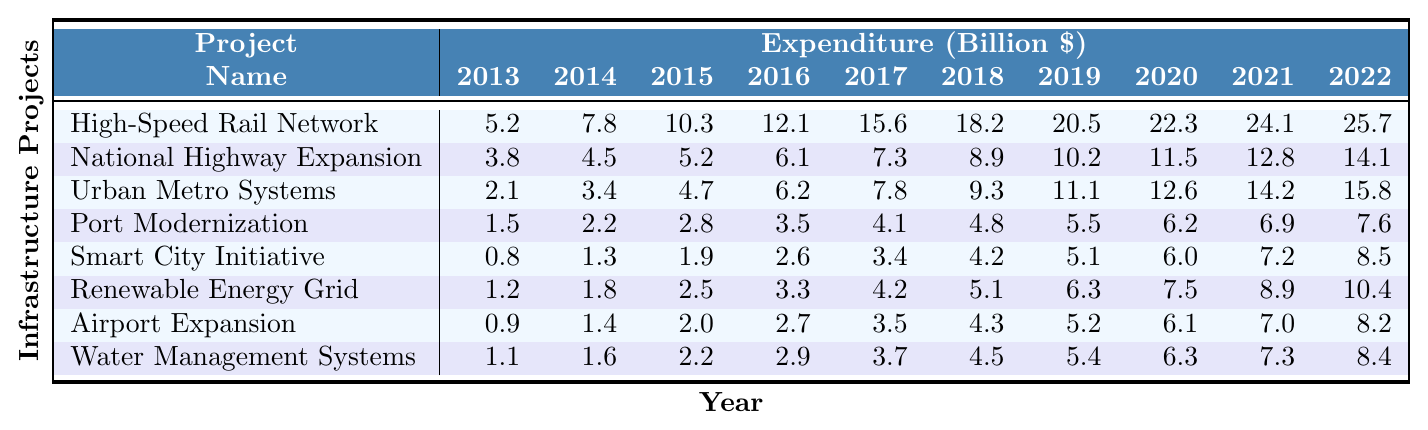What was the highest expenditure in the year 2022? By inspecting the table, the expenditures for 2022 across various projects are: High-Speed Rail Network (25.7), National Highway Expansion (14.1), Urban Metro Systems (15.8), Port Modernization (7.6), Smart City Initiative (8.5), Renewable Energy Grid (10.4), Airport Expansion (8.2), and Water Management Systems (8.4). The highest among these is 25.7 from the High-Speed Rail Network.
Answer: 25.7 Which project had the lowest expenditure in 2013? In 2013, the expenditures for the projects are as follows: High-Speed Rail Network (5.2), National Highway Expansion (3.8), Urban Metro Systems (2.1), Port Modernization (1.5), Smart City Initiative (0.8), Renewable Energy Grid (1.2), Airport Expansion (0.9), and Water Management Systems (1.1). The lowest expenditure is 0.8 from the Smart City Initiative.
Answer: 0.8 What is the average expenditure for the Urban Metro Systems over the decade? The expenditures for Urban Metro Systems are: 2.1, 3.4, 4.7, 6.2, 7.8, 9.3, 11.1, 12.6, 14.2, and 15.8. First, sum them up: (2.1 + 3.4 + 4.7 + 6.2 + 7.8 + 9.3 + 11.1 + 12.6 + 14.2 + 15.8) = 77.2. There are 10 data points, so the average is 77.2 divided by 10, which equals 7.72.
Answer: 7.72 Did the expenditure for the Renewable Energy Grid increase every year from 2013 to 2022? Looking at the table for the Renewable Energy Grid, the expenditures are: 1.2, 1.8, 2.5, 3.3, 4.2, 5.1, 6.3, 7.5, 8.9, and 10.4. Each subsequent year shows a higher expenditure than the previous year. Thus, yes, it did increase every year.
Answer: Yes What was the total expenditure for all projects in 2020? To find the total expenditure in 2020, add up each project’s expenditure: High-Speed Rail Network (22.3), National Highway Expansion (11.5), Urban Metro Systems (12.6), Port Modernization (6.2), Smart City Initiative (6.0), Renewable Energy Grid (7.5), Airport Expansion (6.1), and Water Management Systems (6.3). The total is: (22.3 + 11.5 + 12.6 + 6.2 + 6.0 + 7.5 + 6.1 + 6.3) = 78.5.
Answer: 78.5 Which project saw the largest increase in expenditure from 2013 to 2022? By calculating the differences for each project: High-Speed Rail Network (25.7 - 5.2 = 20.5), National Highway Expansion (14.1 - 3.8 = 10.3), Urban Metro Systems (15.8 - 2.1 = 13.7), Port Modernization (7.6 - 1.5 = 6.1), Smart City Initiative (8.5 - 0.8 = 7.7), Renewable Energy Grid (10.4 - 1.2 = 9.2), Airport Expansion (8.2 - 0.9 = 7.3), Water Management Systems (8.4 - 1.1 = 7.3). The largest increase is from the High-Speed Rail Network at 20.5.
Answer: High-Speed Rail Network What percentage of the total expenditure in 2022 was spent on the High-Speed Rail Network? First, sum the expenditures for all projects in 2022: High-Speed Rail Network (25.7), National Highway Expansion (14.1), Urban Metro Systems (15.8), Port Modernization (7.6), Smart City Initiative (8.5), Renewable Energy Grid (10.4), Airport Expansion (8.2), and Water Management Systems (8.4). The total is 25.7 + 14.1 + 15.8 + 7.6 + 8.5 + 10.4 + 8.2 + 8.4 = 98.7. The expenditure on High-Speed Rail Network is 25.7, so the percentage is (25.7 / 98.7) * 100 = 26.0%.
Answer: 26.0% In which year did the Smart City Initiative reach an expenditure of 5 billion dollars? Looking at the Smart City Initiative expenditures, it reached 5 billion dollars in 2019, where the expenditure was 5.1 billion dollars, which is the first year it exceeded 5 billion.
Answer: 2019 